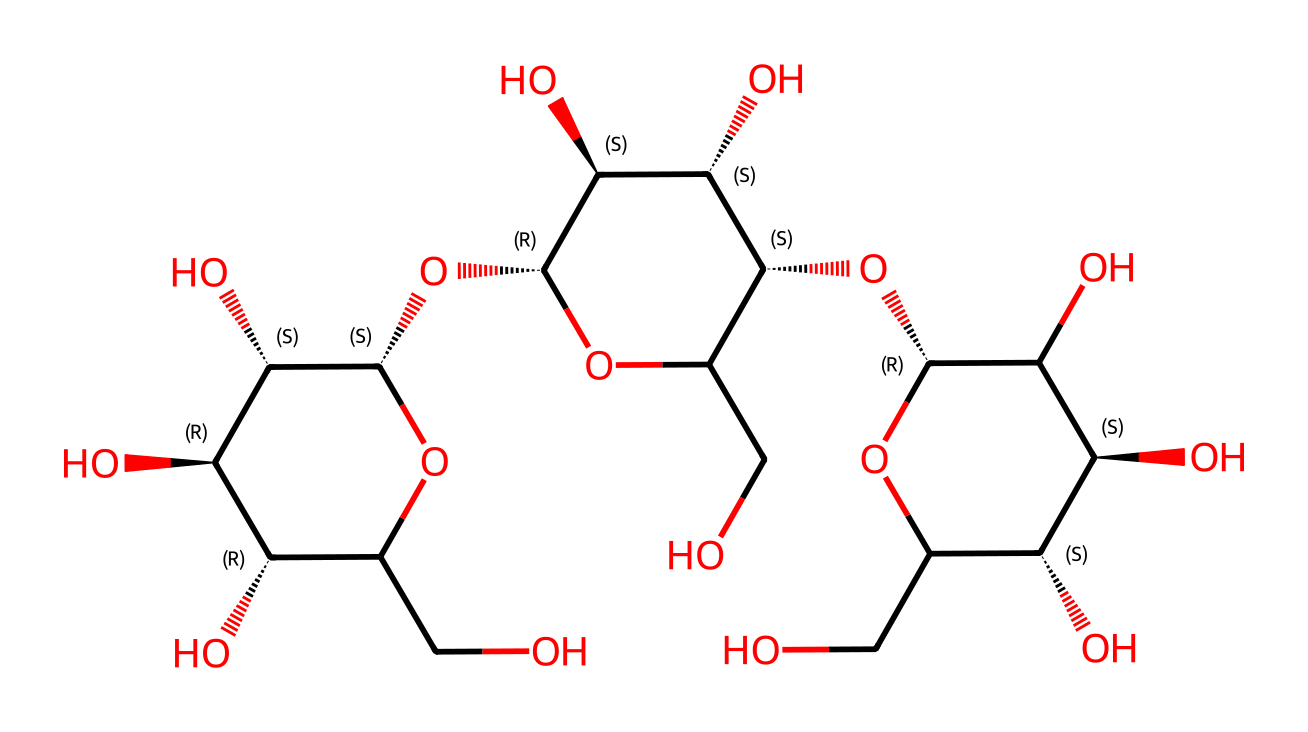What is the composition of the repeating unit in cellulose? Cellulose is composed of glucose units linked by β(1→4) glycosidic bonds. The structure represents multiple glucose residues, which are the repeating units in cellulose.
Answer: glucose How many oxygen atoms are present in the molecule? By analyzing the chemical structure, we can count the number of oxygen atoms, which appears multiple times in the SMILES structure. There are 6 oxygen atoms in the cellulose structure provided.
Answer: 6 What type of bonding is prevalent in cellulose? The backbone of cellulose is formed by glycosidic bonds linking the glucose units, indicating that covalent bonding is predominant throughout the structure.
Answer: covalent How many hydroxyl groups are indicated in the structure? Hydroxyl groups are denoted by the [OH] notation and appear several times in the SMILES structure. After examining the structure, it is determined that there are 7 hydroxyl groups present in the cellulose molecule.
Answer: 7 What is the significance of the β(1→4) linkage in cellulose? The β(1→4) linkage contributes to the linear and rigid structure of cellulose, making it insoluble in water and providing strength to plant cell walls. This structure also affects its mechanical properties, making it suitable for high-performance paper.
Answer: mechanical properties What is the primary source of cellulose used in office paper production? The primary source of cellulose for high-performance office paper is pulp derived from trees, such as eucalyptus and pine, which are rich in cellulose fibers.
Answer: trees 